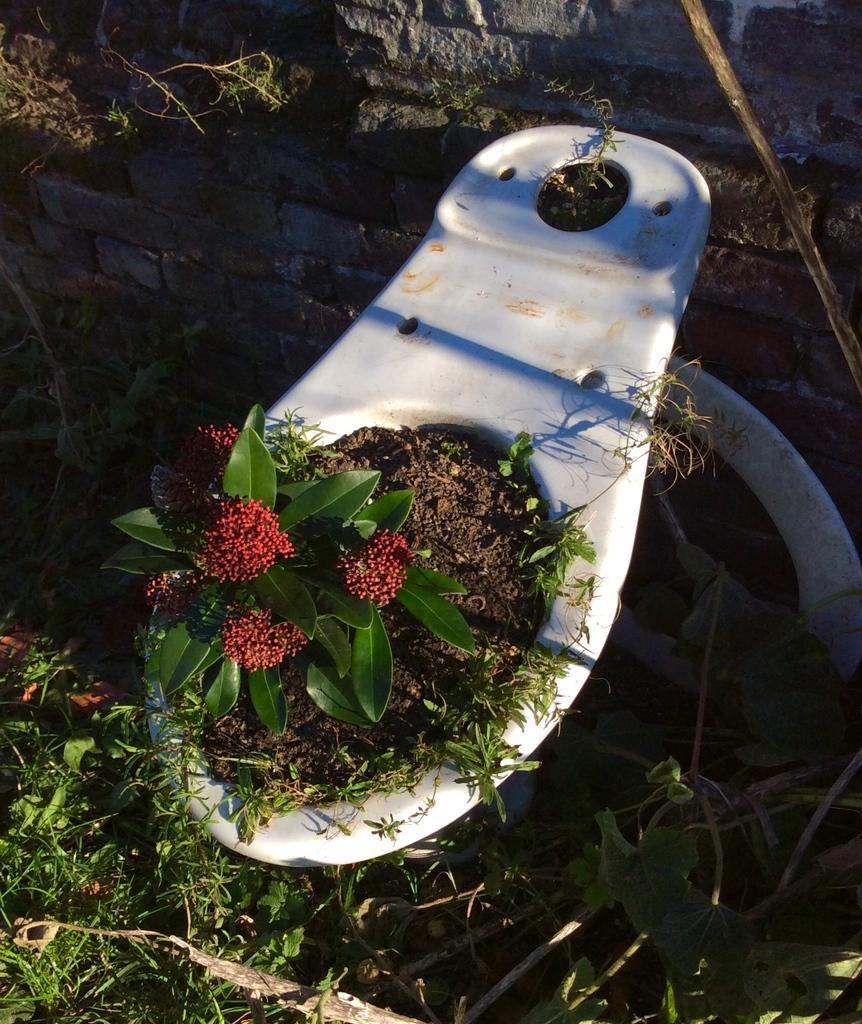Could you give a brief overview of what you see in this image? Here in this picture we can see the ground is covered with grass and in the middle we can see some thing and in that we can see a plant and we can also see some flowers on it. 